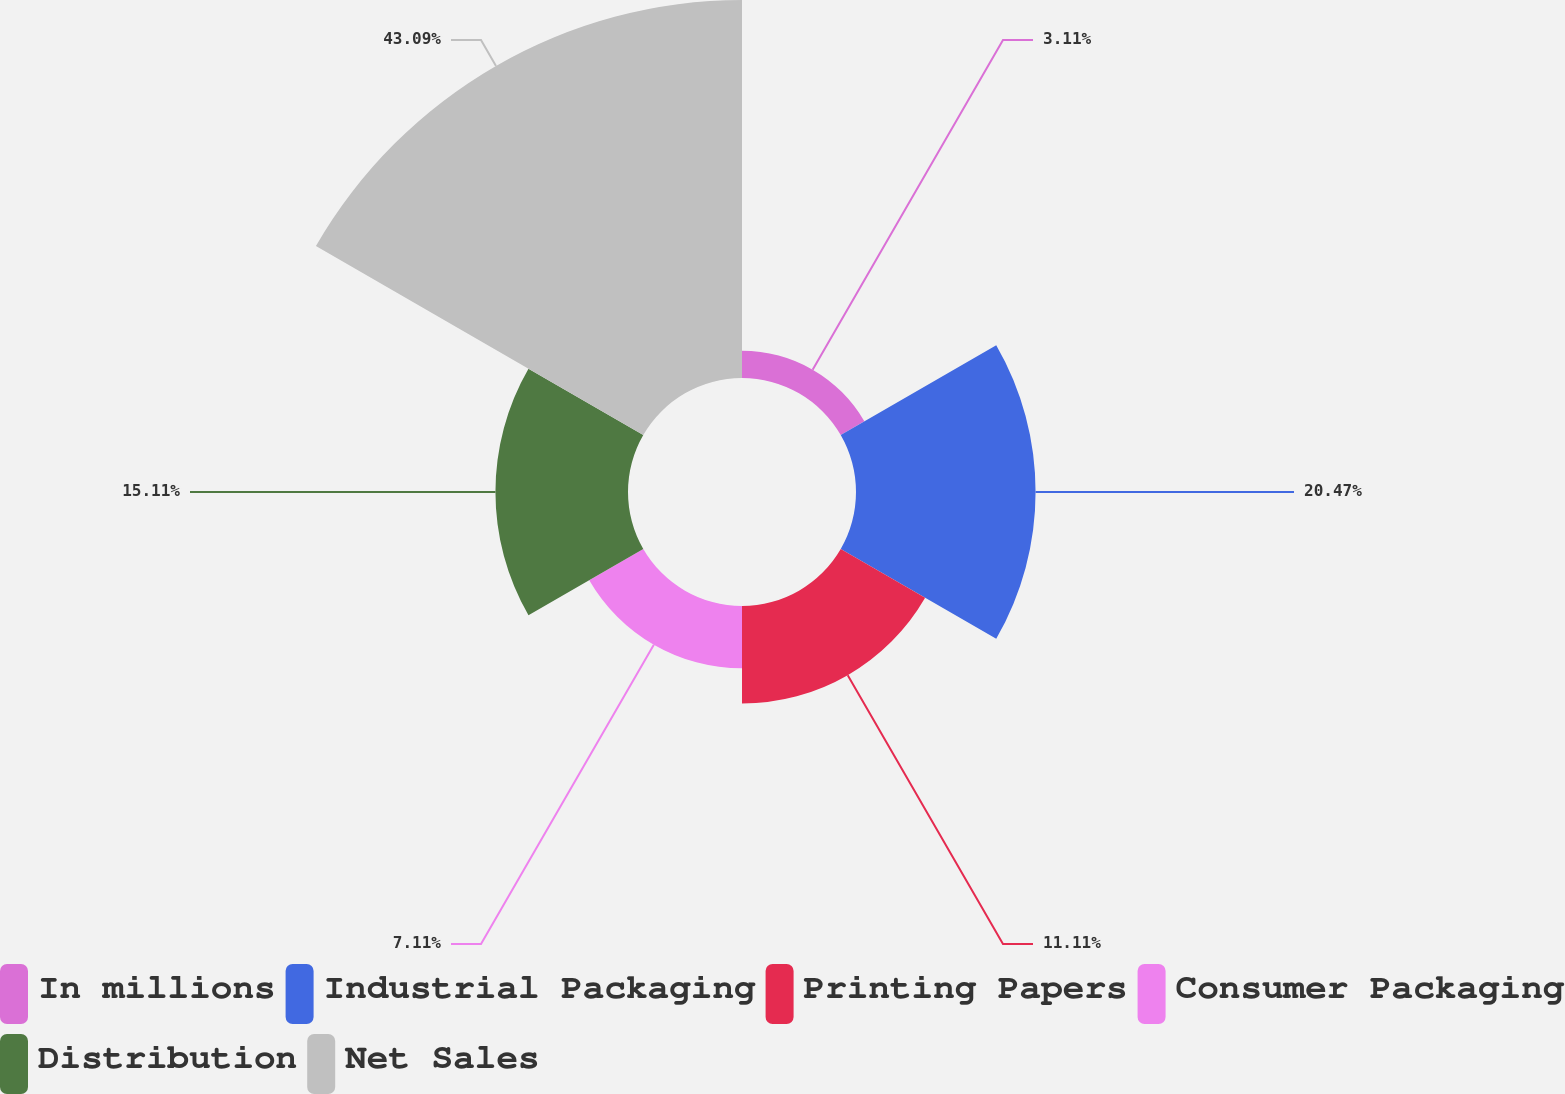Convert chart to OTSL. <chart><loc_0><loc_0><loc_500><loc_500><pie_chart><fcel>In millions<fcel>Industrial Packaging<fcel>Printing Papers<fcel>Consumer Packaging<fcel>Distribution<fcel>Net Sales<nl><fcel>3.11%<fcel>20.47%<fcel>11.11%<fcel>7.11%<fcel>15.11%<fcel>43.09%<nl></chart> 